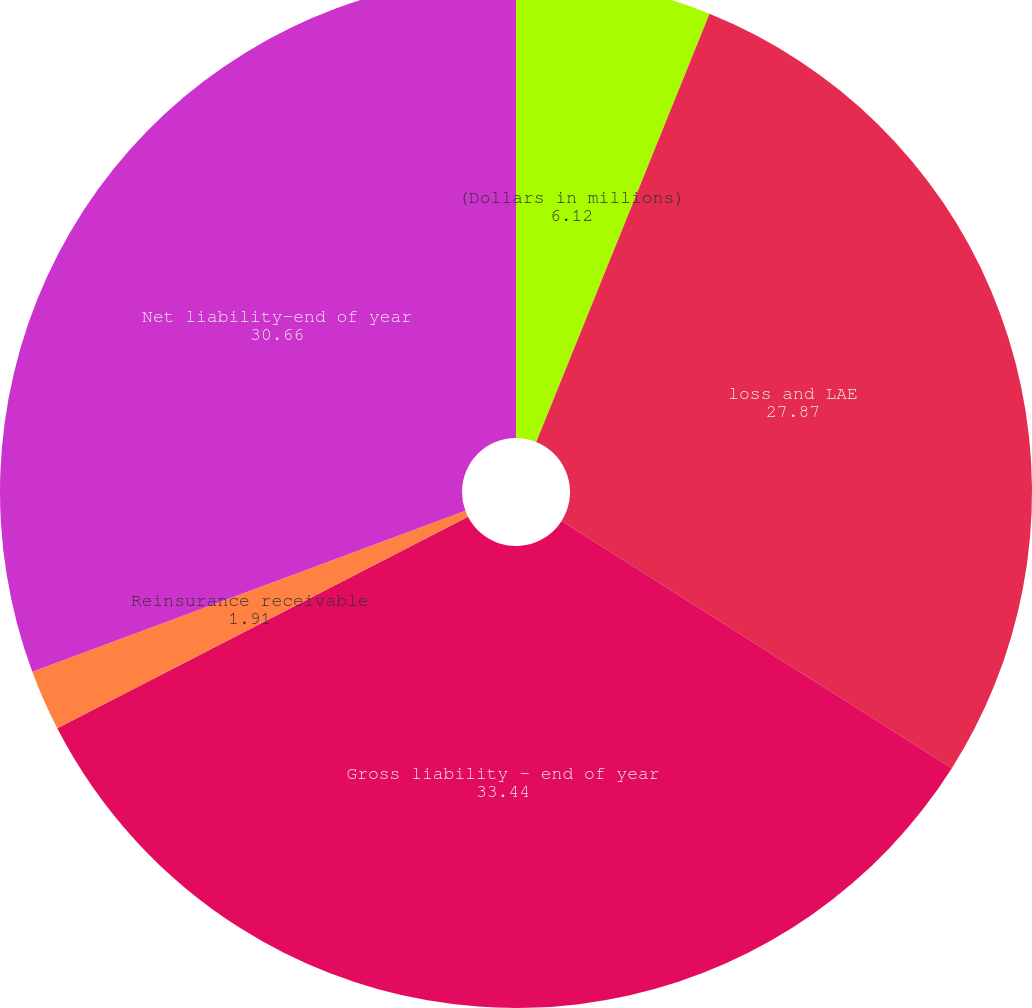<chart> <loc_0><loc_0><loc_500><loc_500><pie_chart><fcel>(Dollars in millions)<fcel>loss and LAE<fcel>Gross liability - end of year<fcel>Reinsurance receivable<fcel>Net liability-end of year<nl><fcel>6.12%<fcel>27.87%<fcel>33.44%<fcel>1.91%<fcel>30.66%<nl></chart> 